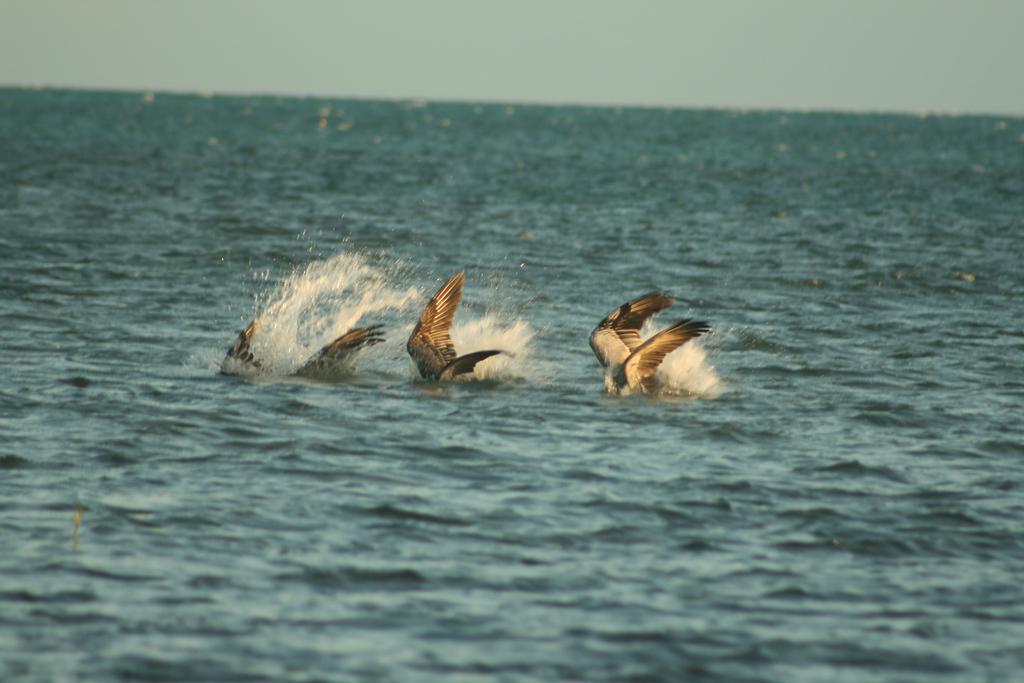Could you give a brief overview of what you see in this image? In this image we can see the sea, one object in the sea, it looks like three birds with wings in the water and it looks like the sky at the top of the image. 